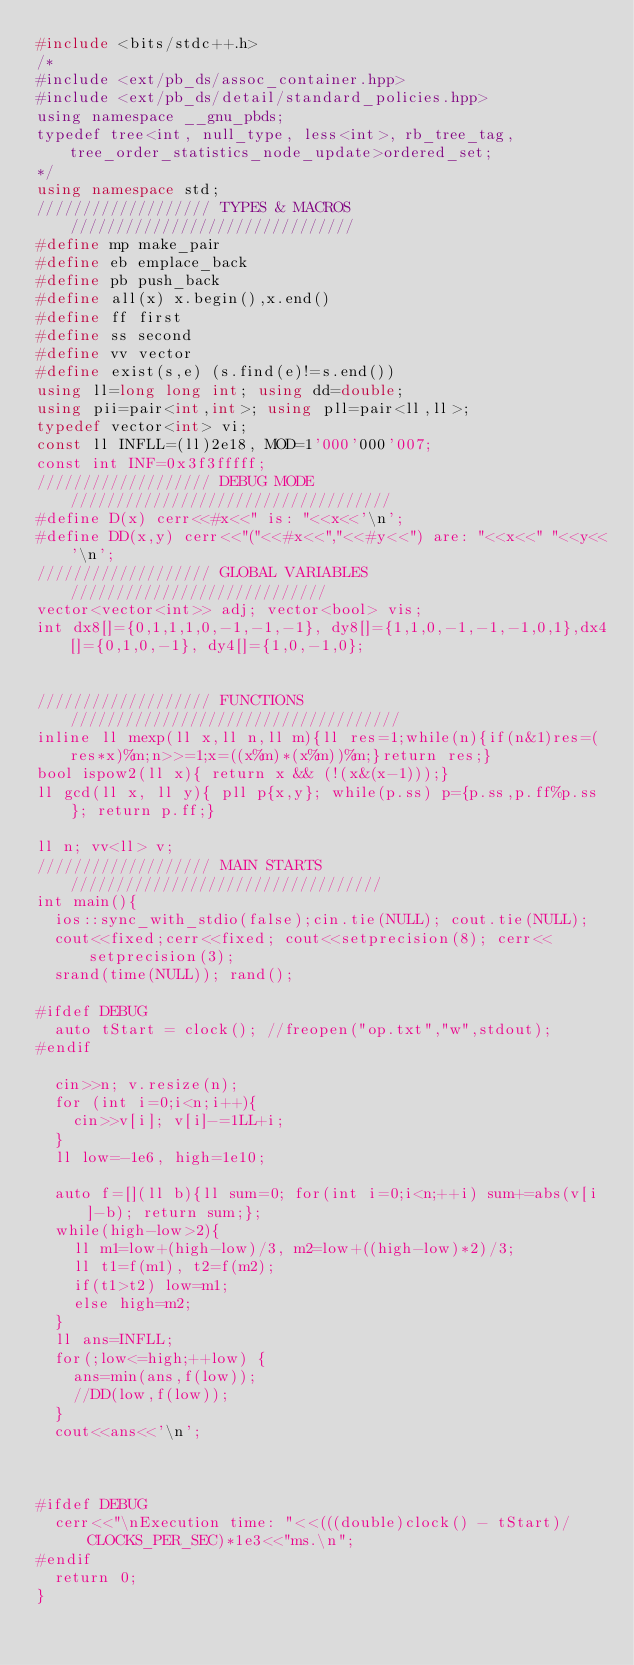Convert code to text. <code><loc_0><loc_0><loc_500><loc_500><_C++_>#include <bits/stdc++.h>
/*
#include <ext/pb_ds/assoc_container.hpp>
#include <ext/pb_ds/detail/standard_policies.hpp>
using namespace __gnu_pbds;
typedef tree<int, null_type, less<int>, rb_tree_tag, tree_order_statistics_node_update>ordered_set;
*/
using namespace std;
/////////////////// TYPES & MACROS ///////////////////////////////
#define mp make_pair
#define eb emplace_back
#define pb push_back
#define all(x) x.begin(),x.end()
#define ff first
#define ss second
#define vv vector
#define exist(s,e) (s.find(e)!=s.end())
using ll=long long int; using dd=double;
using pii=pair<int,int>; using pll=pair<ll,ll>;
typedef vector<int> vi;
const ll INFLL=(ll)2e18, MOD=1'000'000'007;
const int INF=0x3f3fffff;
/////////////////// DEBUG MODE ///////////////////////////////////
#define D(x) cerr<<#x<<" is: "<<x<<'\n';
#define DD(x,y) cerr<<"("<<#x<<","<<#y<<") are: "<<x<<" "<<y<<'\n';
/////////////////// GLOBAL VARIABLES ////////////////////////////
vector<vector<int>> adj; vector<bool> vis;
int dx8[]={0,1,1,1,0,-1,-1,-1}, dy8[]={1,1,0,-1,-1,-1,0,1},dx4[]={0,1,0,-1}, dy4[]={1,0,-1,0};


/////////////////// FUNCTIONS ////////////////////////////////////
inline ll mexp(ll x,ll n,ll m){ll res=1;while(n){if(n&1)res=(res*x)%m;n>>=1;x=((x%m)*(x%m))%m;}return res;}
bool ispow2(ll x){ return x && (!(x&(x-1)));}
ll gcd(ll x, ll y){ pll p{x,y}; while(p.ss) p={p.ss,p.ff%p.ss}; return p.ff;}

ll n; vv<ll> v;
/////////////////// MAIN STARTS //////////////////////////////////
int main(){
  ios::sync_with_stdio(false);cin.tie(NULL); cout.tie(NULL);
  cout<<fixed;cerr<<fixed; cout<<setprecision(8); cerr<<setprecision(3);
  srand(time(NULL)); rand();

#ifdef DEBUG
  auto tStart = clock(); //freopen("op.txt","w",stdout);
#endif

  cin>>n; v.resize(n);
  for (int i=0;i<n;i++){
    cin>>v[i]; v[i]-=1LL+i;
  }
  ll low=-1e6, high=1e10;

  auto f=[](ll b){ll sum=0; for(int i=0;i<n;++i) sum+=abs(v[i]-b); return sum;};
  while(high-low>2){
    ll m1=low+(high-low)/3, m2=low+((high-low)*2)/3;
    ll t1=f(m1), t2=f(m2);
    if(t1>t2) low=m1;
    else high=m2;
  }
  ll ans=INFLL;
  for(;low<=high;++low) {
    ans=min(ans,f(low));
    //DD(low,f(low));
  }
  cout<<ans<<'\n';



#ifdef DEBUG
	cerr<<"\nExecution time: "<<(((double)clock() - tStart)/CLOCKS_PER_SEC)*1e3<<"ms.\n";
#endif
  return 0;
}
</code> 